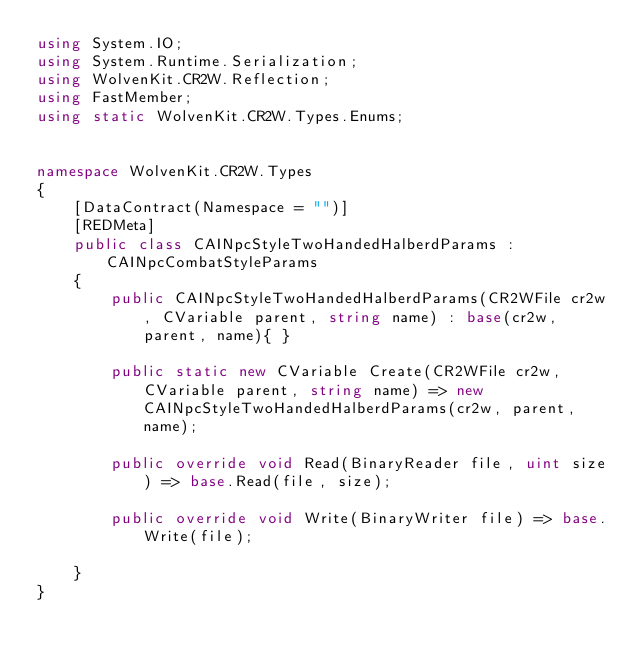Convert code to text. <code><loc_0><loc_0><loc_500><loc_500><_C#_>using System.IO;
using System.Runtime.Serialization;
using WolvenKit.CR2W.Reflection;
using FastMember;
using static WolvenKit.CR2W.Types.Enums;


namespace WolvenKit.CR2W.Types
{
	[DataContract(Namespace = "")]
	[REDMeta]
	public class CAINpcStyleTwoHandedHalberdParams : CAINpcCombatStyleParams
	{
		public CAINpcStyleTwoHandedHalberdParams(CR2WFile cr2w, CVariable parent, string name) : base(cr2w, parent, name){ }

		public static new CVariable Create(CR2WFile cr2w, CVariable parent, string name) => new CAINpcStyleTwoHandedHalberdParams(cr2w, parent, name);

		public override void Read(BinaryReader file, uint size) => base.Read(file, size);

		public override void Write(BinaryWriter file) => base.Write(file);

	}
}</code> 